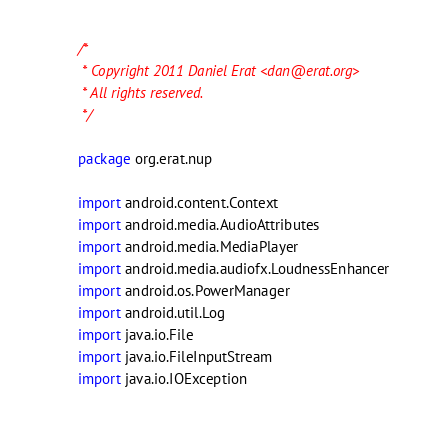Convert code to text. <code><loc_0><loc_0><loc_500><loc_500><_Kotlin_>/*
 * Copyright 2011 Daniel Erat <dan@erat.org>
 * All rights reserved.
 */

package org.erat.nup

import android.content.Context
import android.media.AudioAttributes
import android.media.MediaPlayer
import android.media.audiofx.LoudnessEnhancer
import android.os.PowerManager
import android.util.Log
import java.io.File
import java.io.FileInputStream
import java.io.IOException</code> 